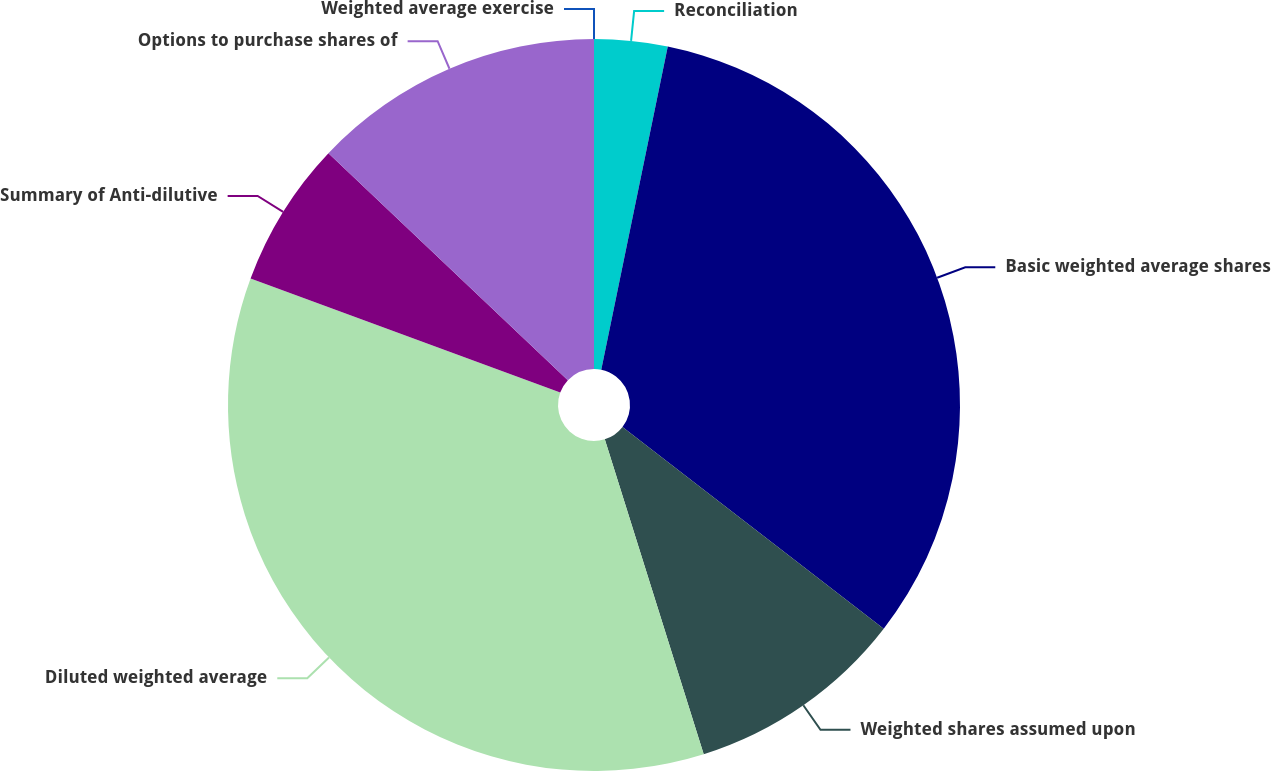<chart> <loc_0><loc_0><loc_500><loc_500><pie_chart><fcel>Reconciliation<fcel>Basic weighted average shares<fcel>Weighted shares assumed upon<fcel>Diluted weighted average<fcel>Summary of Anti-dilutive<fcel>Options to purchase shares of<fcel>Weighted average exercise<nl><fcel>3.23%<fcel>32.23%<fcel>9.69%<fcel>35.46%<fcel>6.46%<fcel>12.92%<fcel>0.0%<nl></chart> 